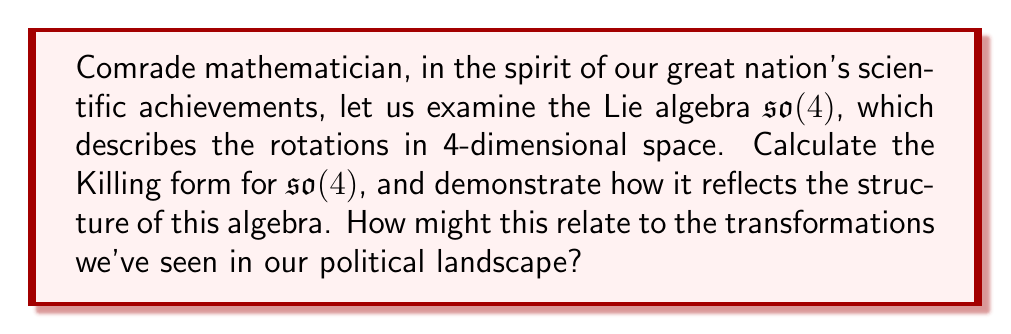Show me your answer to this math problem. Let's approach this step-by-step, comrade:

1) First, recall that $\mathfrak{so}(4)$ is the Lie algebra of $4 \times 4$ skew-symmetric matrices. Its dimension is $\binom{4}{2} = 6$.

2) The Killing form $B(X,Y)$ for a Lie algebra is defined as:

   $$B(X,Y) = \text{tr}(\text{ad}(X) \circ \text{ad}(Y))$$

   where $\text{ad}(X)$ is the adjoint representation of $X$.

3) For $\mathfrak{so}(4)$, we can choose a basis $\{e_1, e_2, e_3, e_4, e_5, e_6\}$ where:

   $$e_1 = \begin{pmatrix} 0 & 1 & 0 & 0 \\ -1 & 0 & 0 & 0 \\ 0 & 0 & 0 & 0 \\ 0 & 0 & 0 & 0 \end{pmatrix}, 
     e_2 = \begin{pmatrix} 0 & 0 & 1 & 0 \\ 0 & 0 & 0 & 0 \\ -1 & 0 & 0 & 0 \\ 0 & 0 & 0 & 0 \end{pmatrix}, 
     e_3 = \begin{pmatrix} 0 & 0 & 0 & 1 \\ 0 & 0 & 0 & 0 \\ 0 & 0 & 0 & 0 \\ -1 & 0 & 0 & 0 \end{pmatrix}$$

   $$e_4 = \begin{pmatrix} 0 & 0 & 0 & 0 \\ 0 & 0 & 1 & 0 \\ 0 & -1 & 0 & 0 \\ 0 & 0 & 0 & 0 \end{pmatrix}, 
     e_5 = \begin{pmatrix} 0 & 0 & 0 & 0 \\ 0 & 0 & 0 & 1 \\ 0 & 0 & 0 & 0 \\ 0 & -1 & 0 & 0 \end{pmatrix}, 
     e_6 = \begin{pmatrix} 0 & 0 & 0 & 0 \\ 0 & 0 & 0 & 0 \\ 0 & 0 & 0 & 1 \\ 0 & 0 & -1 & 0 \end{pmatrix}$$

4) We need to calculate $B(e_i, e_j)$ for all $i,j$. Due to the properties of the Killing form, we know it will be symmetric.

5) Let's calculate $B(e_1, e_1)$ as an example:
   
   $$\text{ad}(e_1)(e_1) = 0$$
   $$\text{ad}(e_1)(e_2) = e_4$$
   $$\text{ad}(e_1)(e_3) = e_5$$
   $$\text{ad}(e_1)(e_4) = -e_2$$
   $$\text{ad}(e_1)(e_5) = -e_3$$
   $$\text{ad}(e_1)(e_6) = 0$$

   Therefore, the matrix of $\text{ad}(e_1)$ in this basis is:

   $$\text{ad}(e_1) = \begin{pmatrix} 0 & 0 & 0 & 0 & 0 & 0 \\ 0 & 0 & 0 & -1 & 0 & 0 \\ 0 & 0 & 0 & 0 & -1 & 0 \\ 0 & 1 & 0 & 0 & 0 & 0 \\ 0 & 0 & 1 & 0 & 0 & 0 \\ 0 & 0 & 0 & 0 & 0 & 0 \end{pmatrix}$$

   $$B(e_1, e_1) = \text{tr}(\text{ad}(e_1) \circ \text{ad}(e_1)) = -4$$

6) Calculating similarly for all pairs, we find that:

   $$B(e_i, e_i) = -4 \text{ for all } i$$
   $$B(e_i, e_j) = 0 \text{ for } i \neq j$$

7) Therefore, the Killing form for $\mathfrak{so}(4)$ in this basis is:

   $$B = -4 \begin{pmatrix} 1 & 0 & 0 & 0 & 0 & 0 \\ 0 & 1 & 0 & 0 & 0 & 0 \\ 0 & 0 & 1 & 0 & 0 & 0 \\ 0 & 0 & 0 & 1 & 0 & 0 \\ 0 & 0 & 0 & 0 & 1 & 0 \\ 0 & 0 & 0 & 0 & 0 & 1 \end{pmatrix}$$

This diagonal form reflects the orthogonality of the chosen basis, much like the clear divisions we saw in our political debates. The negative definite nature of the form indicates that $\mathfrak{so}(4)$ is compact, suggesting a certain stability in its structure, akin to the resilience of our political system despite the turbulent times.
Answer: The Killing form for $\mathfrak{so}(4)$ is $B = -4I_6$, where $I_6$ is the $6 \times 6$ identity matrix. 